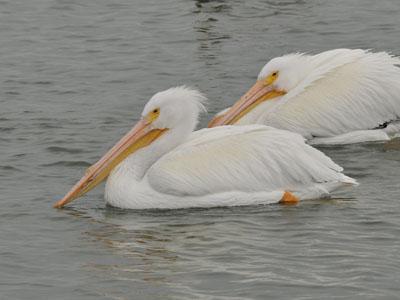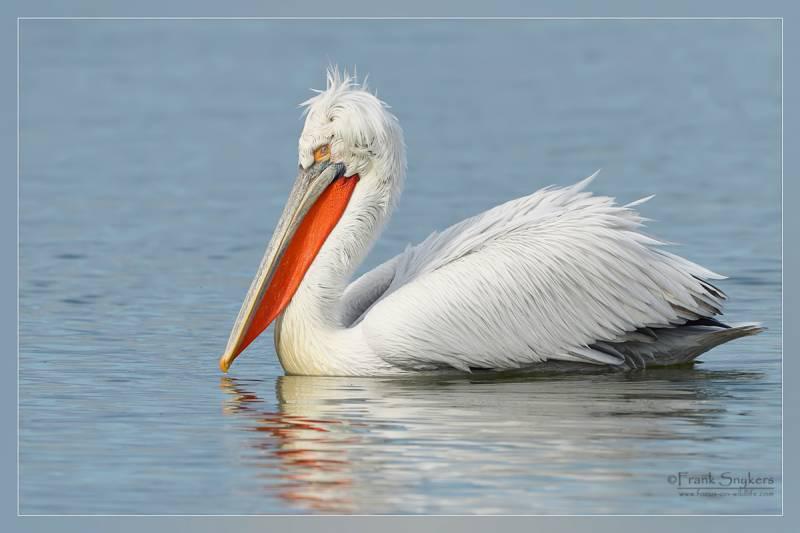The first image is the image on the left, the second image is the image on the right. Assess this claim about the two images: "The left image shows two pelicans on the water.". Correct or not? Answer yes or no. Yes. 